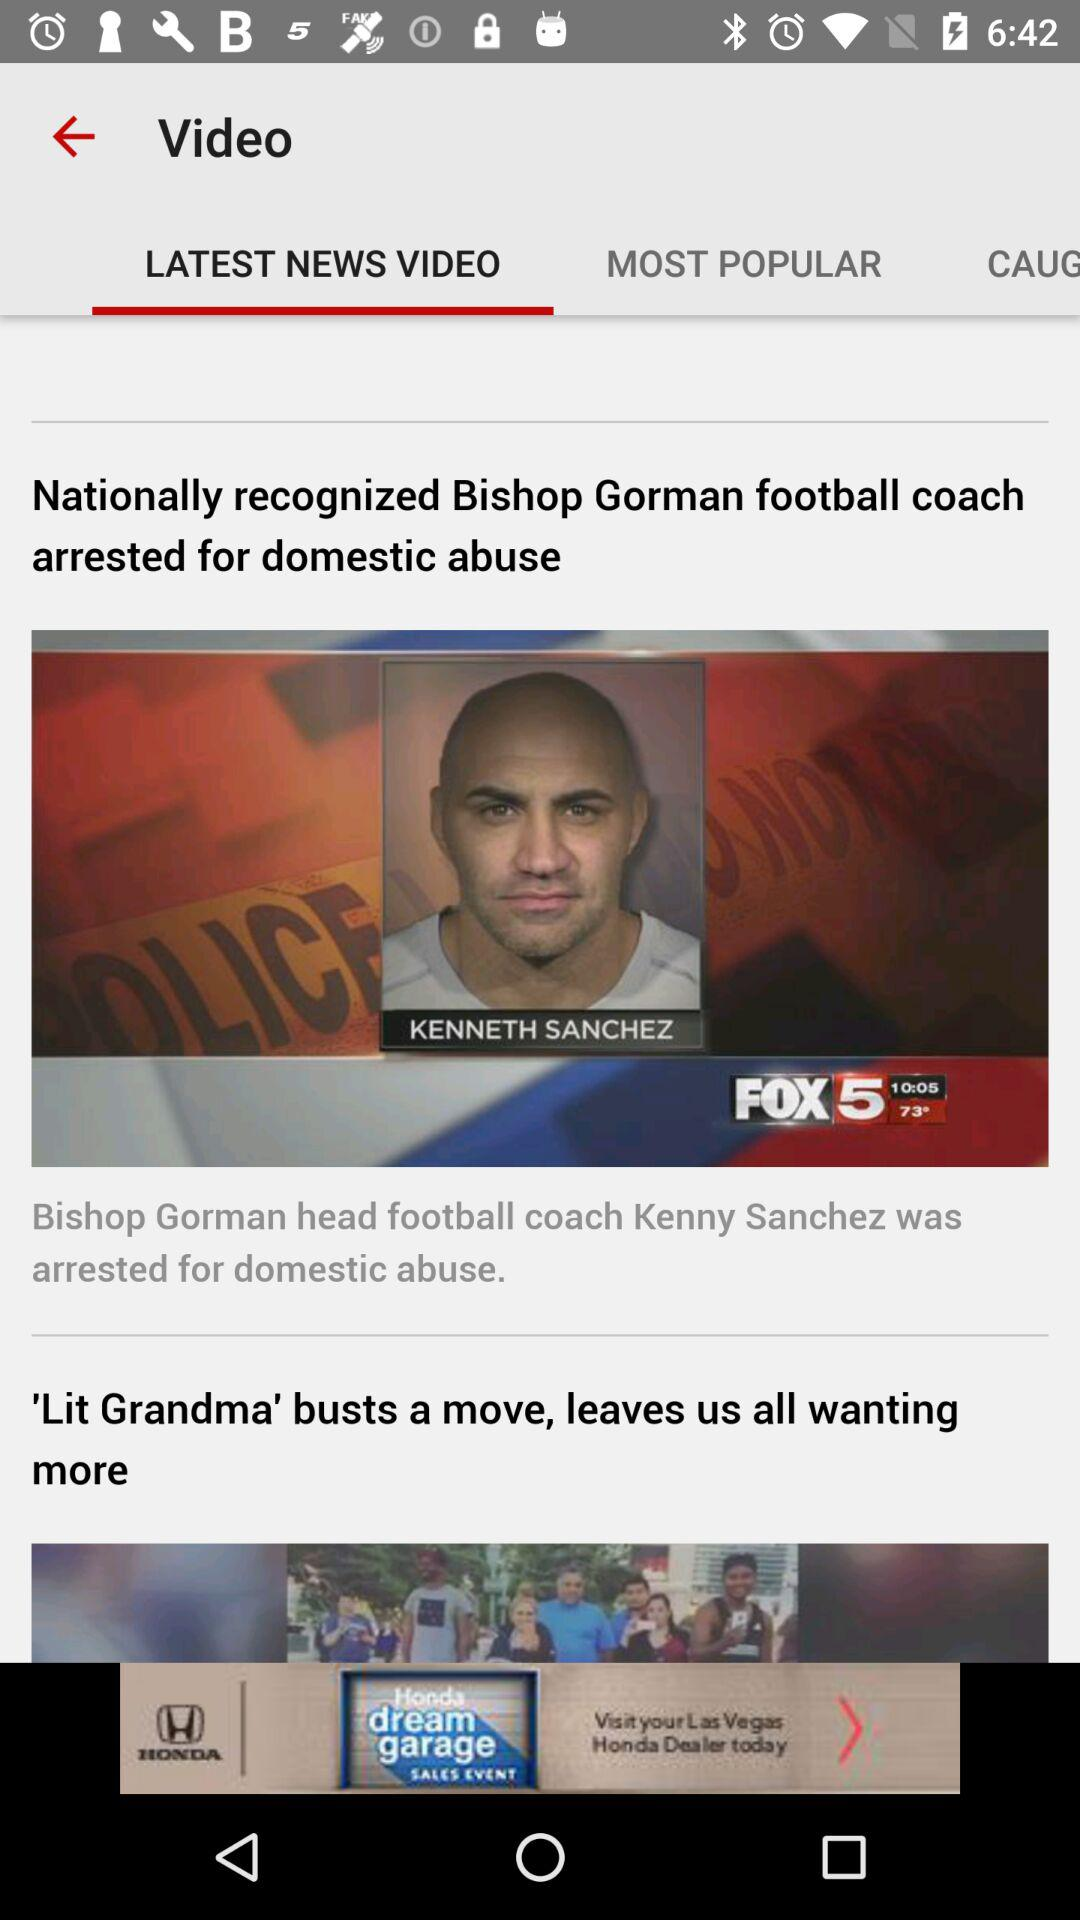Which tab is selected? The selected tab is "LATEST NEWS VIDEO". 